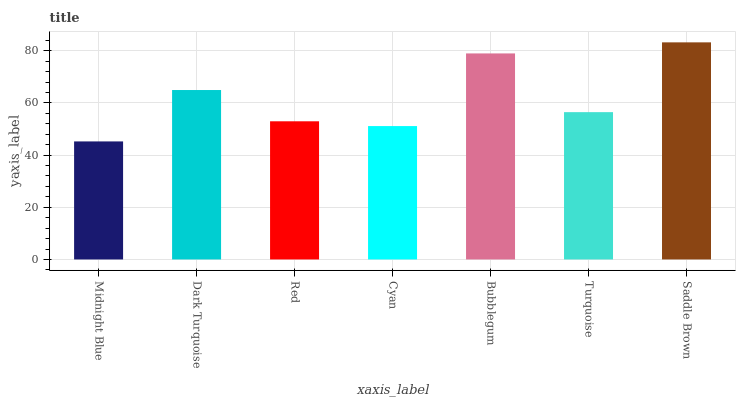Is Dark Turquoise the minimum?
Answer yes or no. No. Is Dark Turquoise the maximum?
Answer yes or no. No. Is Dark Turquoise greater than Midnight Blue?
Answer yes or no. Yes. Is Midnight Blue less than Dark Turquoise?
Answer yes or no. Yes. Is Midnight Blue greater than Dark Turquoise?
Answer yes or no. No. Is Dark Turquoise less than Midnight Blue?
Answer yes or no. No. Is Turquoise the high median?
Answer yes or no. Yes. Is Turquoise the low median?
Answer yes or no. Yes. Is Dark Turquoise the high median?
Answer yes or no. No. Is Dark Turquoise the low median?
Answer yes or no. No. 